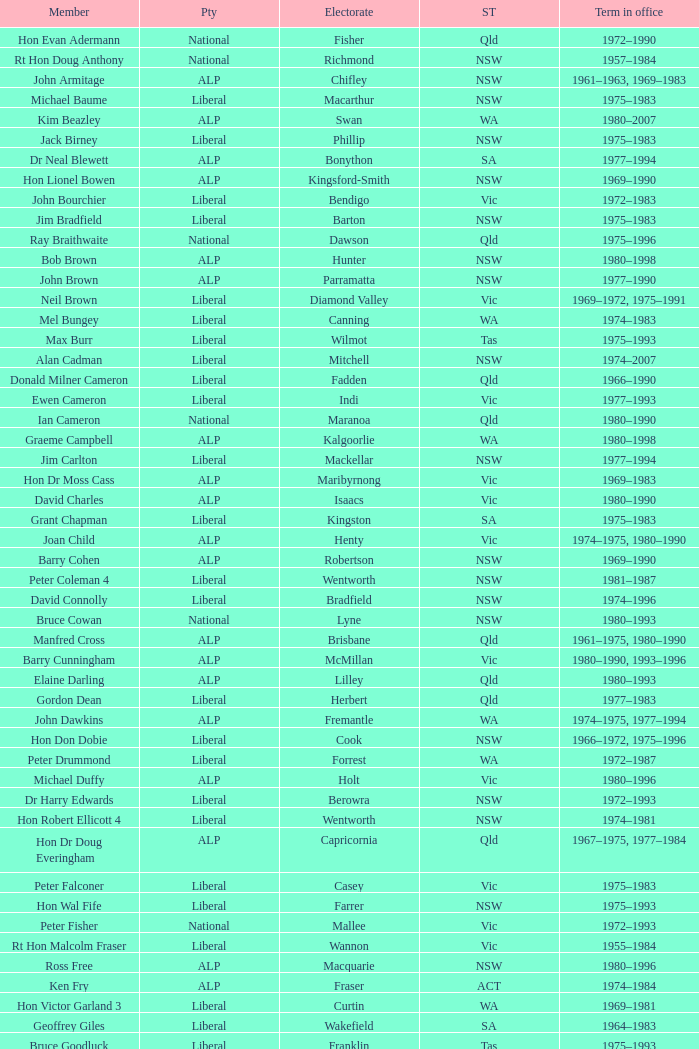When was Hon Les Johnson in office? 1955–1966, 1969–1984. 